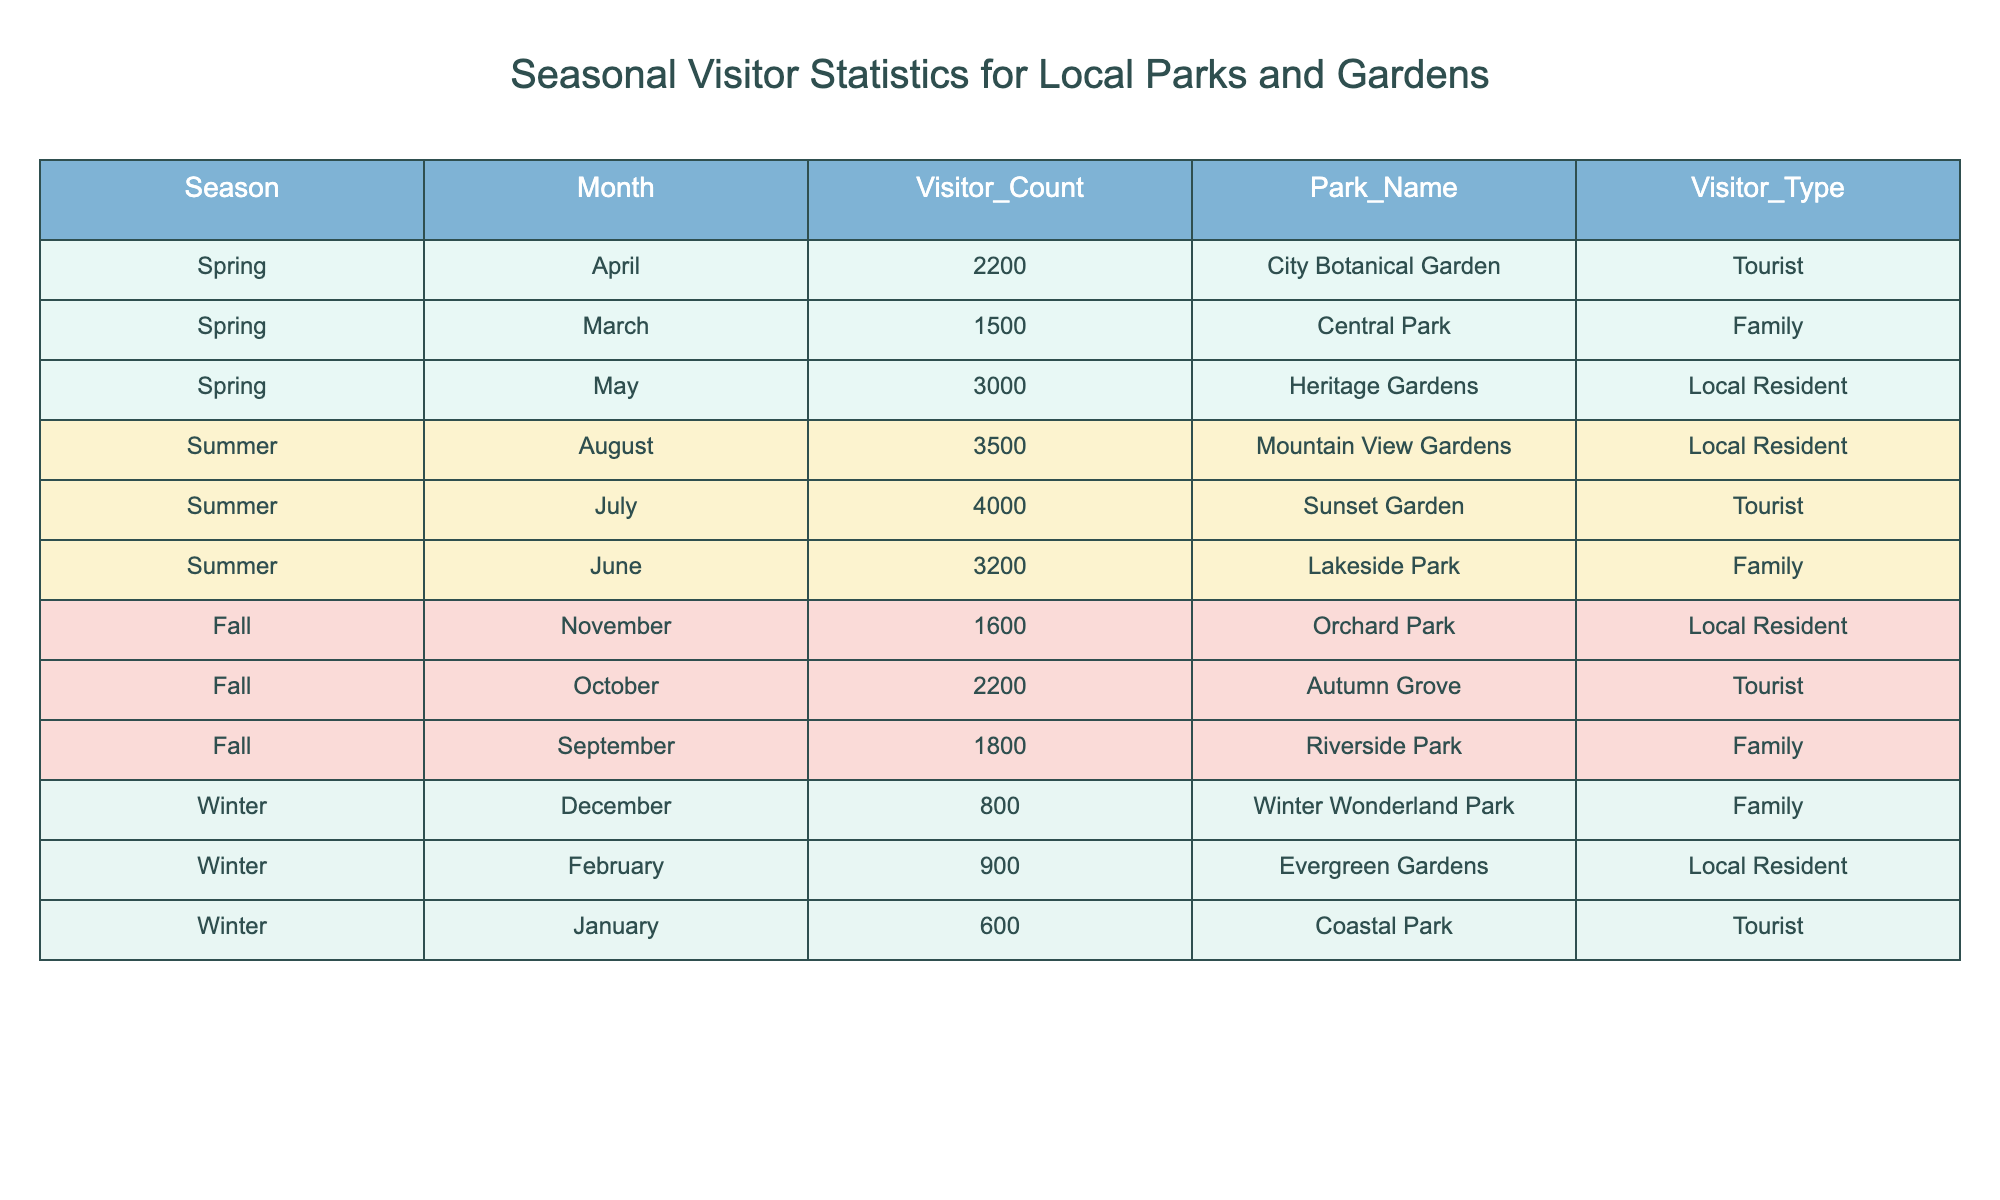What is the total visitor count for Heritage Gardens across all seasons? The visitor count for Heritage Gardens appears only in May, which is 3000. Therefore, the total visitor count for Heritage Gardens across all seasons is 3000.
Answer: 3000 Which park had the most visitors in July? In July, Sunset Garden had the highest visitor count of 4000.
Answer: Sunset Garden How many family visitors did Lakeside Park receive in the summer? The only data for Lakeside Park in the summer is located in June, which shows 3200 family visitors.
Answer: 3200 What is the average visitor count for the Tourist type across all seasons? The Visitor counts for Tourist types are: 2200 (April) + 4000 (July) + 2200 (October) + 600 (January), totaling 10200. There are 4 entries, so the average is 10200 / 4 = 2550.
Answer: 2550 Did any park receive more than 3000 visitors in a fall month? In the fall months, the visitor counts for September (1800), October (2200), and November (1600) do not exceed 3000. Therefore, no park received more than 3000 visitors in fall.
Answer: No Which season had the highest overall visitor count? To determine the season with the highest visitor count, we sum the counts: Spring (1500 + 2200 + 3000 = 6700), Summer (3200 + 4000 + 3500 = 10700), Fall (1800 + 2200 + 1600 = 5600), Winter (800 + 600 + 900 = 2300). The summer has the highest total at 10700.
Answer: Summer What is the difference in visitor count between the month with the highest total visitors and the month with the lowest? The month with the highest visitor count is July with 4000 visitors, while the month with the lowest is January with 600. The difference is 4000 - 600 = 3400.
Answer: 3400 Which months had more than 2000 visitors? The months with more than 2000 visitors are April (2200), May (3000), June (3200), July (4000), August (3500), October (2200).
Answer: April, May, June, July, August, October In which month did local residents visit the least? Local resident visits are recorded in May (3000), August (3500), November (1600), and February (900). February shows the least with 900 visitors.
Answer: February 